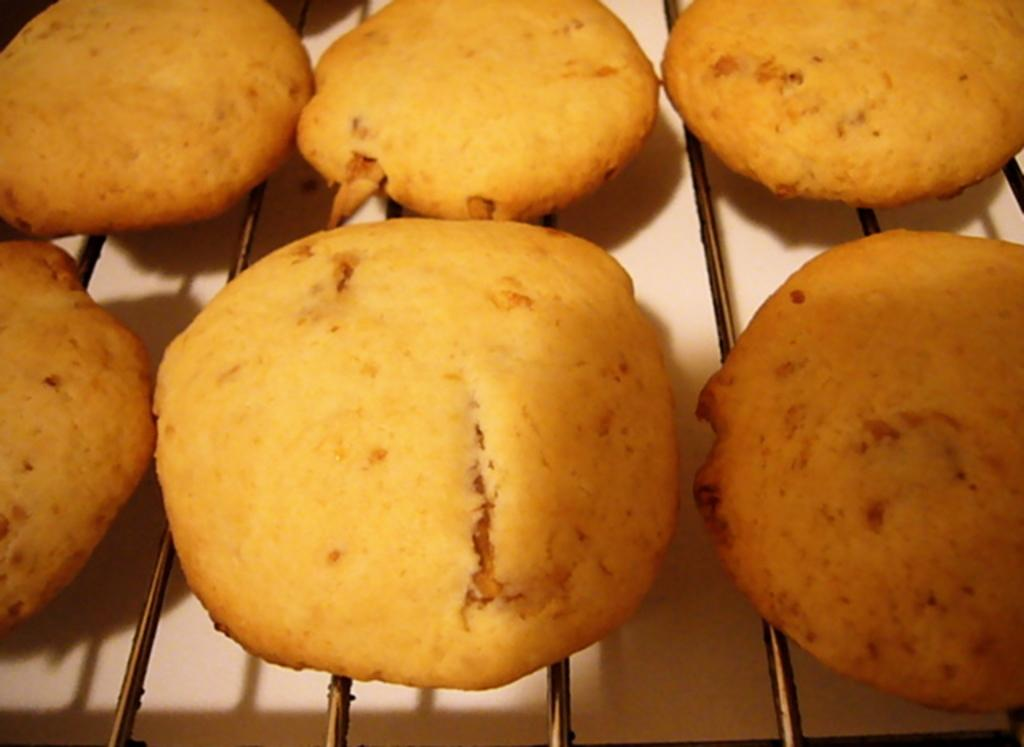What type of food is on the grill in the image? There are cookies on a grill in the image. What is the color of the surface the grill is on? The grill is on a white surface. What type of shoe is visible in the image? There is no shoe present in the image. 